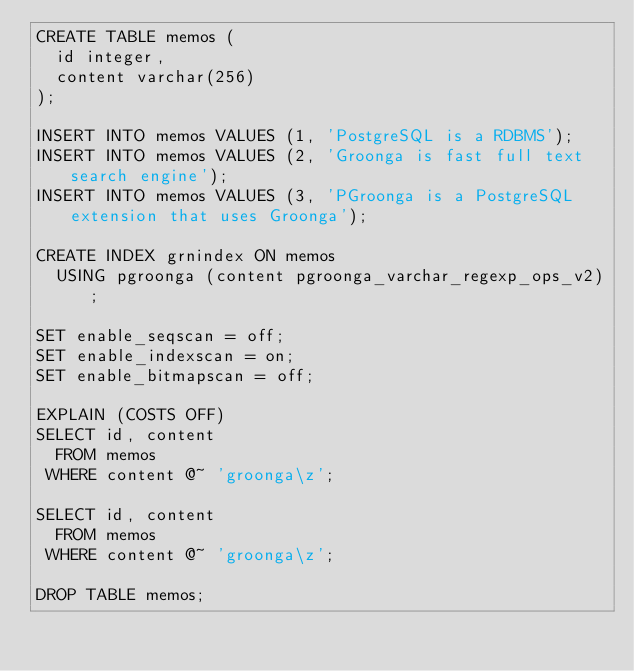Convert code to text. <code><loc_0><loc_0><loc_500><loc_500><_SQL_>CREATE TABLE memos (
  id integer,
  content varchar(256)
);

INSERT INTO memos VALUES (1, 'PostgreSQL is a RDBMS');
INSERT INTO memos VALUES (2, 'Groonga is fast full text search engine');
INSERT INTO memos VALUES (3, 'PGroonga is a PostgreSQL extension that uses Groonga');

CREATE INDEX grnindex ON memos
  USING pgroonga (content pgroonga_varchar_regexp_ops_v2);

SET enable_seqscan = off;
SET enable_indexscan = on;
SET enable_bitmapscan = off;

EXPLAIN (COSTS OFF)
SELECT id, content
  FROM memos
 WHERE content @~ 'groonga\z';

SELECT id, content
  FROM memos
 WHERE content @~ 'groonga\z';

DROP TABLE memos;
</code> 